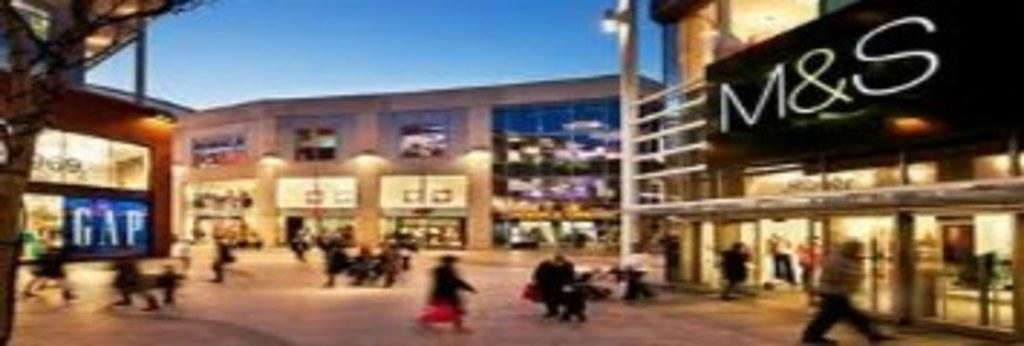What type of structures are present in the image? There are buildings in the image. Can you identify any specific signage or text in the image? Yes, there is a board with the text "M&S" on the right side of the image. What is the activity of the people in the image? There are people walking in the image. What type of vegetation is on the left side of the image? There is a tree on the left side of the image. What is visible in the background of the image? The sky is visible in the image. What type of carriage is being pulled by the horse in the image? There is no horse or carriage present in the image. What type of pleasure can be seen being enjoyed by the people in the image? The image does not depict any specific pleasure being enjoyed by the people; they are simply walking. 